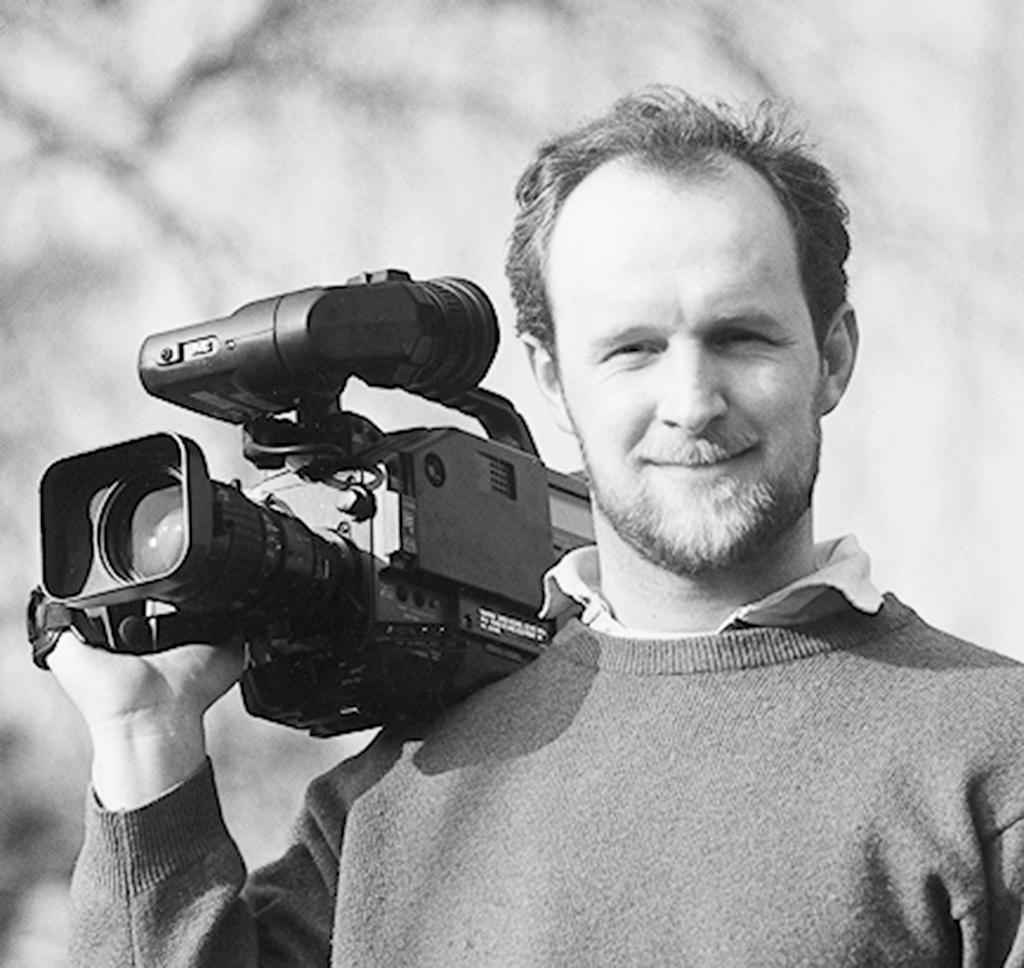What is the color scheme of the image? The image is black and white. What is the main subject of the image? There is a man in the image. What is the man holding in his hand? The man is holding a camera with his hand. What type of soap is the man using to clean the camera in the image? There is no soap or cleaning activity present in the image; the man is simply holding a camera. What type of jelly can be seen on the man's shirt in the image? There is no jelly or any food item present on the man's shirt in the image. 